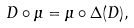<formula> <loc_0><loc_0><loc_500><loc_500>D \circ \mu = \mu \circ \Delta ( D ) ,</formula> 